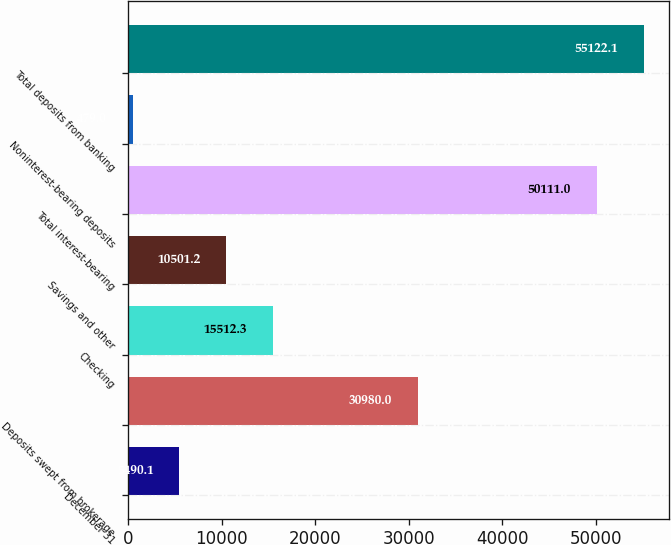<chart> <loc_0><loc_0><loc_500><loc_500><bar_chart><fcel>December 31<fcel>Deposits swept from brokerage<fcel>Checking<fcel>Savings and other<fcel>Total interest-bearing<fcel>Noninterest-bearing deposits<fcel>Total deposits from banking<nl><fcel>5490.1<fcel>30980<fcel>15512.3<fcel>10501.2<fcel>50111<fcel>479<fcel>55122.1<nl></chart> 